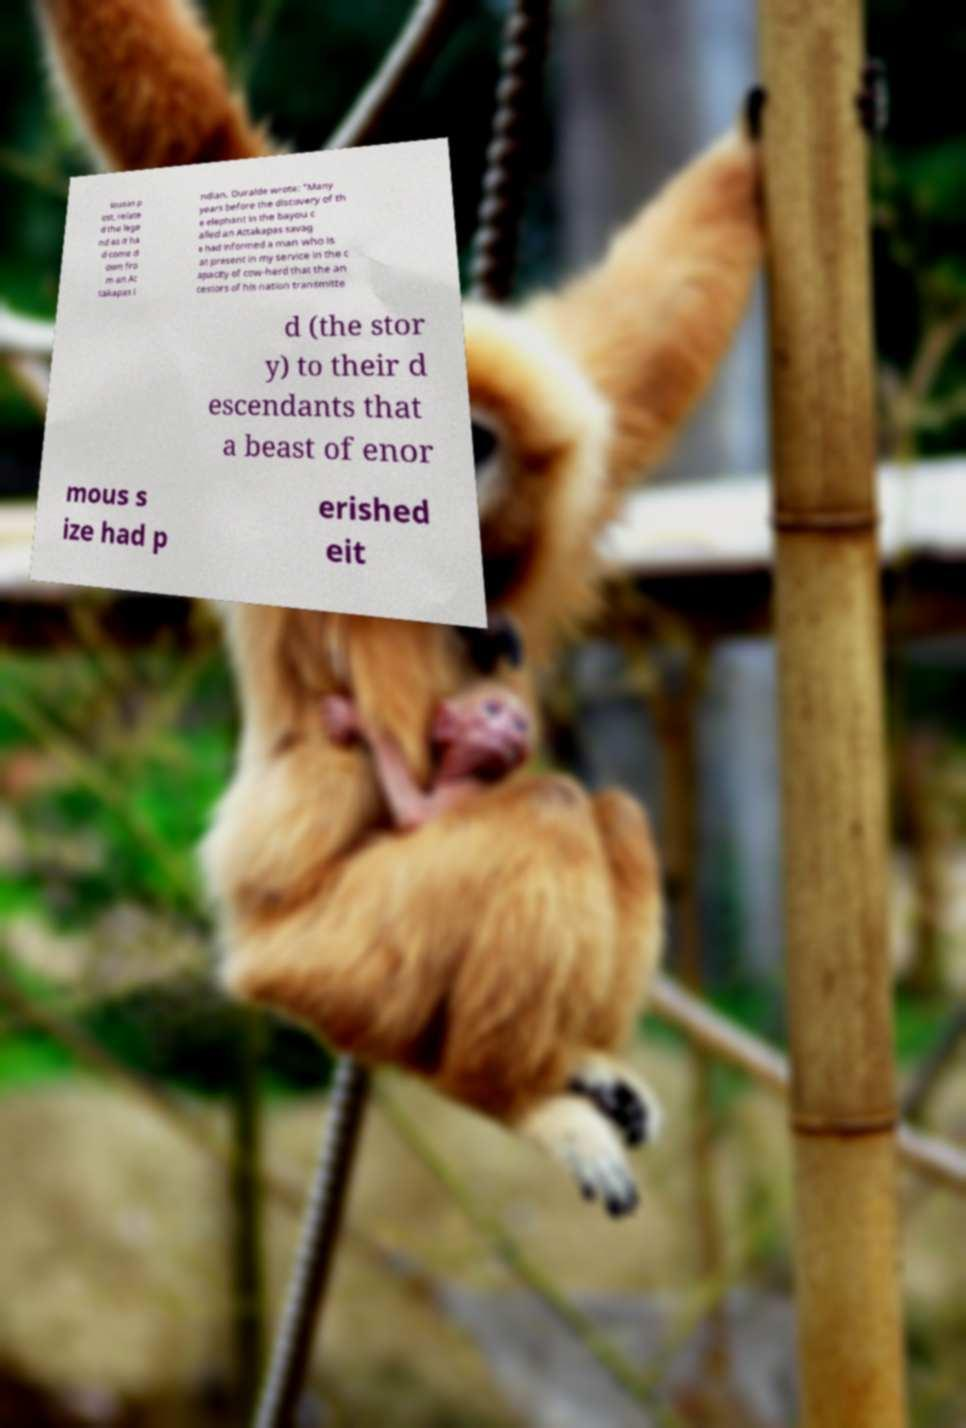Could you assist in decoding the text presented in this image and type it out clearly? lousas p ost, relate d the lege nd as it ha d come d own fro m an At takapas I ndian. Duralde wrote: "Many years before the discovery of th e elephant in the bayou c alled an Attakapas savag e had informed a man who is at present in my service in the c apacity of cow-herd that the an cestors of his nation transmitte d (the stor y) to their d escendants that a beast of enor mous s ize had p erished eit 